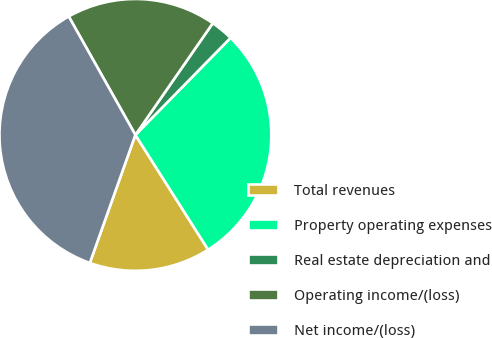<chart> <loc_0><loc_0><loc_500><loc_500><pie_chart><fcel>Total revenues<fcel>Property operating expenses<fcel>Real estate depreciation and<fcel>Operating income/(loss)<fcel>Net income/(loss)<nl><fcel>14.43%<fcel>28.66%<fcel>2.7%<fcel>17.8%<fcel>36.4%<nl></chart> 